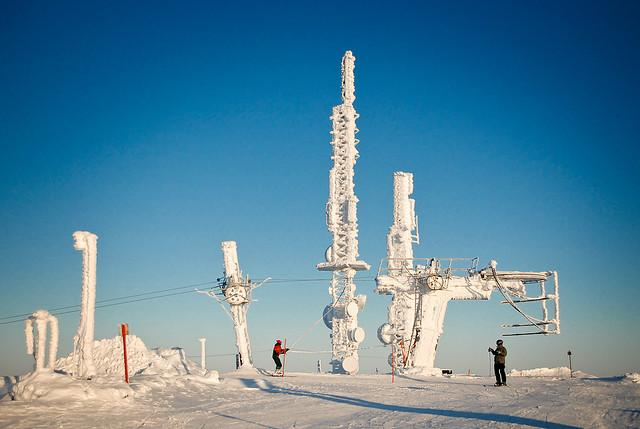Why is the machinery white? snow 